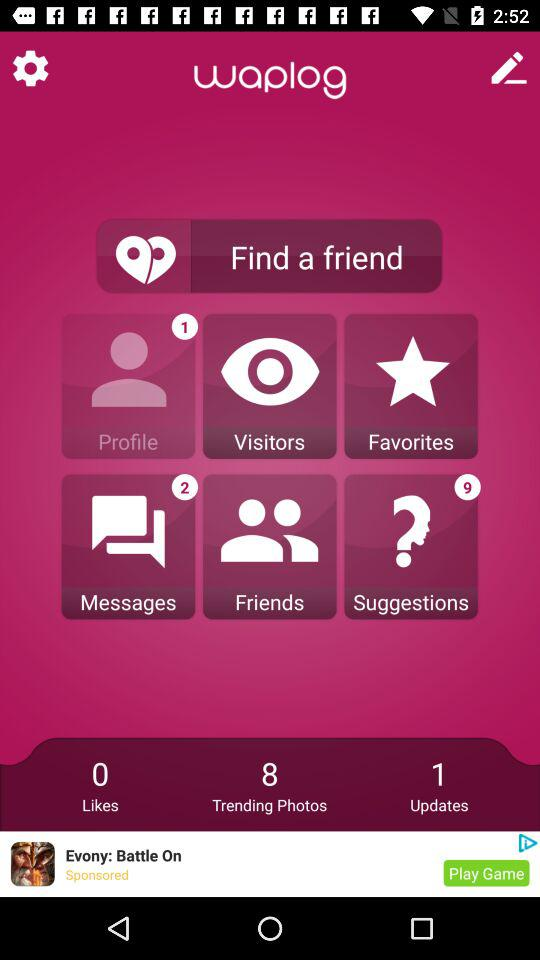How many unread messages are there? There are 2 unread messages. 